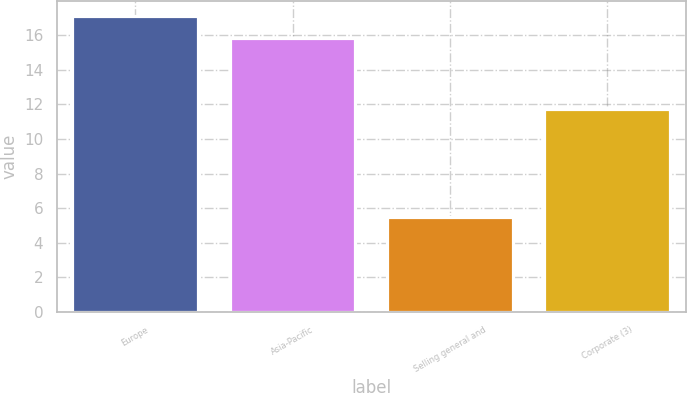Convert chart. <chart><loc_0><loc_0><loc_500><loc_500><bar_chart><fcel>Europe<fcel>Asia-Pacific<fcel>Selling general and<fcel>Corporate (3)<nl><fcel>17.1<fcel>15.8<fcel>5.5<fcel>11.7<nl></chart> 